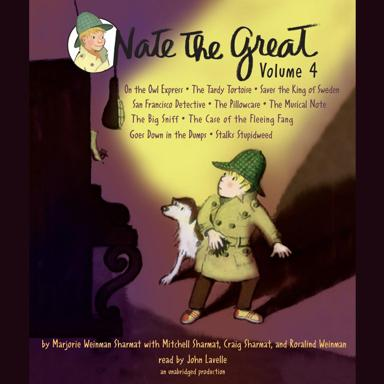What is the title of Volume 4 mentioned in the image? The title of Volume 4 mentioned in the image is 'Nate The Great Volume 4'. This series is known for its engaging mystery stories aimed at young readers. 